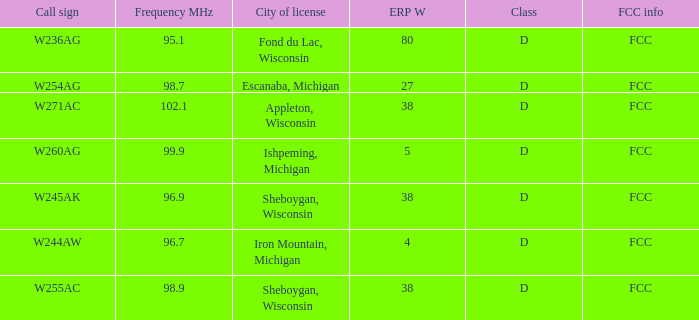Can you give me this table as a dict? {'header': ['Call sign', 'Frequency MHz', 'City of license', 'ERP W', 'Class', 'FCC info'], 'rows': [['W236AG', '95.1', 'Fond du Lac, Wisconsin', '80', 'D', 'FCC'], ['W254AG', '98.7', 'Escanaba, Michigan', '27', 'D', 'FCC'], ['W271AC', '102.1', 'Appleton, Wisconsin', '38', 'D', 'FCC'], ['W260AG', '99.9', 'Ishpeming, Michigan', '5', 'D', 'FCC'], ['W245AK', '96.9', 'Sheboygan, Wisconsin', '38', 'D', 'FCC'], ['W244AW', '96.7', 'Iron Mountain, Michigan', '4', 'D', 'FCC'], ['W255AC', '98.9', 'Sheboygan, Wisconsin', '38', 'D', 'FCC']]} What was the ERP W for 96.7 MHz? 4.0. 